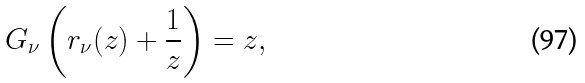Convert formula to latex. <formula><loc_0><loc_0><loc_500><loc_500>G _ { \nu } \left ( r _ { \nu } ( z ) + \frac { 1 } { z } \right ) = z ,</formula> 